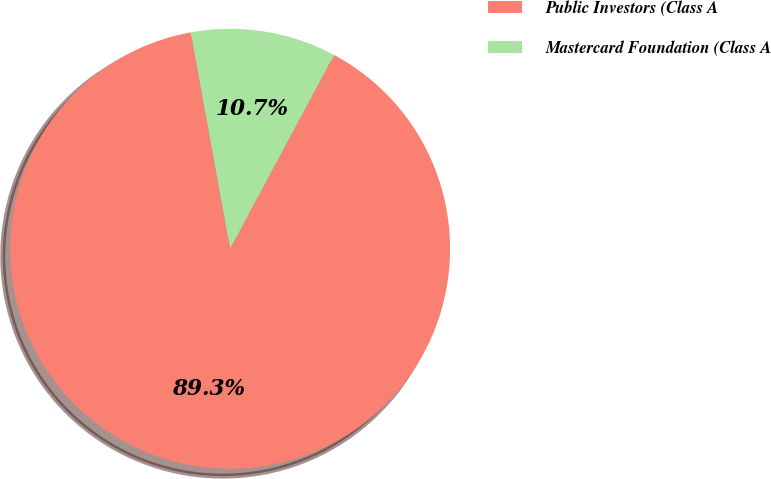Convert chart. <chart><loc_0><loc_0><loc_500><loc_500><pie_chart><fcel>Public Investors (Class A<fcel>Mastercard Foundation (Class A<nl><fcel>89.3%<fcel>10.7%<nl></chart> 